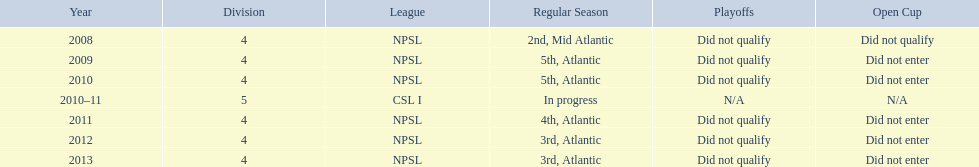In which most recent year did they secure 3rd place? 2013. 